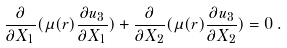<formula> <loc_0><loc_0><loc_500><loc_500>\frac { \partial } { \partial X _ { 1 } } ( \mu ( r ) \frac { \partial u _ { 3 } } { \partial X _ { 1 } } ) + \frac { \partial } { \partial X _ { 2 } } ( \mu ( r ) \frac { \partial u _ { 3 } } { \partial X _ { 2 } } ) = 0 \, .</formula> 